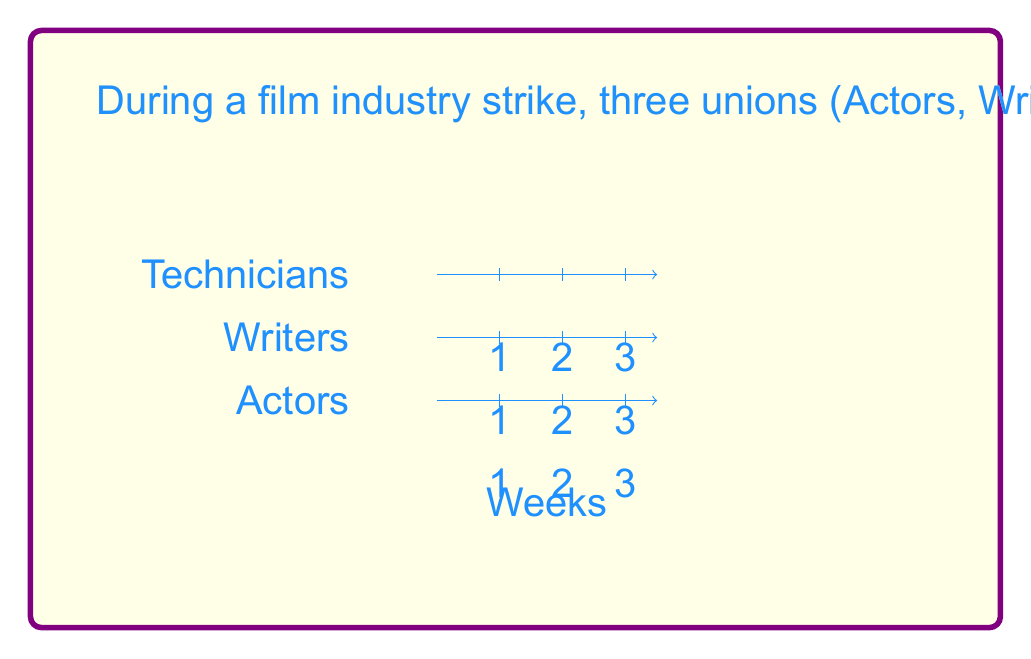Help me with this question. Let's approach this step-by-step:

1) First, we need to consider all possible combinations of strike durations for the three unions. We can represent this as a tuple $(a, b, c)$ where $a$, $b$, and $c$ are the strike durations for Actors, Writers, and Technicians respectively.

2) The constraint is that $1 \leq a, b, c \leq 3$ and $a + b + c \leq 6$.

3) Let's enumerate the possibilities:
   - $(1, 1, 1)$, $(1, 1, 2)$, $(1, 1, 3)$
   - $(1, 2, 1)$, $(1, 2, 2)$, $(1, 2, 3)$
   - $(1, 3, 1)$, $(1, 3, 2)$
   - $(2, 1, 1)$, $(2, 1, 2)$, $(2, 1, 3)$
   - $(2, 2, 1)$, $(2, 2, 2)$
   - $(2, 3, 1)$
   - $(3, 1, 1)$, $(3, 1, 2)$
   - $(3, 2, 1)$

4) Counting these up, we get 18 possible combinations.

5) However, the question asks for the number of different schedules. For each combination, we need to consider the order in which the unions strike.

6) For each combination, the number of possible orders is given by the multinomial coefficient:

   $$\binom{a+b+c}{a,b,c} = \frac{(a+b+c)!}{a!b!c!}$$

7) Let's calculate this for each combination:
   - For $(1,1,1)$: $\binom{3}{1,1,1} = 6$
   - For $(1,1,2)$, $(1,2,1)$, $(2,1,1)$: $\binom{4}{1,1,2} = 12$ each
   - For $(1,1,3)$, $(1,3,1)$, $(3,1,1)$: $\binom{5}{1,1,3} = 20$ each
   - For $(1,2,2)$, $(2,1,2)$, $(2,2,1)$: $\binom{5}{1,2,2} = 30$ each
   - For $(1,2,3)$, $(1,3,2)$, $(2,1,3)$, $(2,3,1)$, $(3,1,2)$, $(3,2,1)$: $\binom{6}{1,2,3} = 60$ each
   - For $(2,2,2)$: $\binom{6}{2,2,2} = 90$

8) Sum up all these possibilities:
   $6 + 3(12) + 3(20) + 3(30) + 6(60) + 90 = 666$

Therefore, there are 666 different possible strike schedules.
Answer: 666 